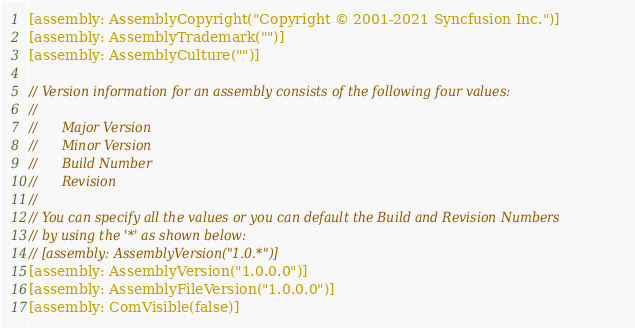<code> <loc_0><loc_0><loc_500><loc_500><_C#_>[assembly: AssemblyCopyright("Copyright © 2001-2021 Syncfusion Inc.")]
[assembly: AssemblyTrademark("")]
[assembly: AssemblyCulture("")]

// Version information for an assembly consists of the following four values:
//
//      Major Version
//      Minor Version 
//      Build Number
//      Revision
//
// You can specify all the values or you can default the Build and Revision Numbers 
// by using the '*' as shown below:
// [assembly: AssemblyVersion("1.0.*")]
[assembly: AssemblyVersion("1.0.0.0")]
[assembly: AssemblyFileVersion("1.0.0.0")]
[assembly: ComVisible(false)]</code> 